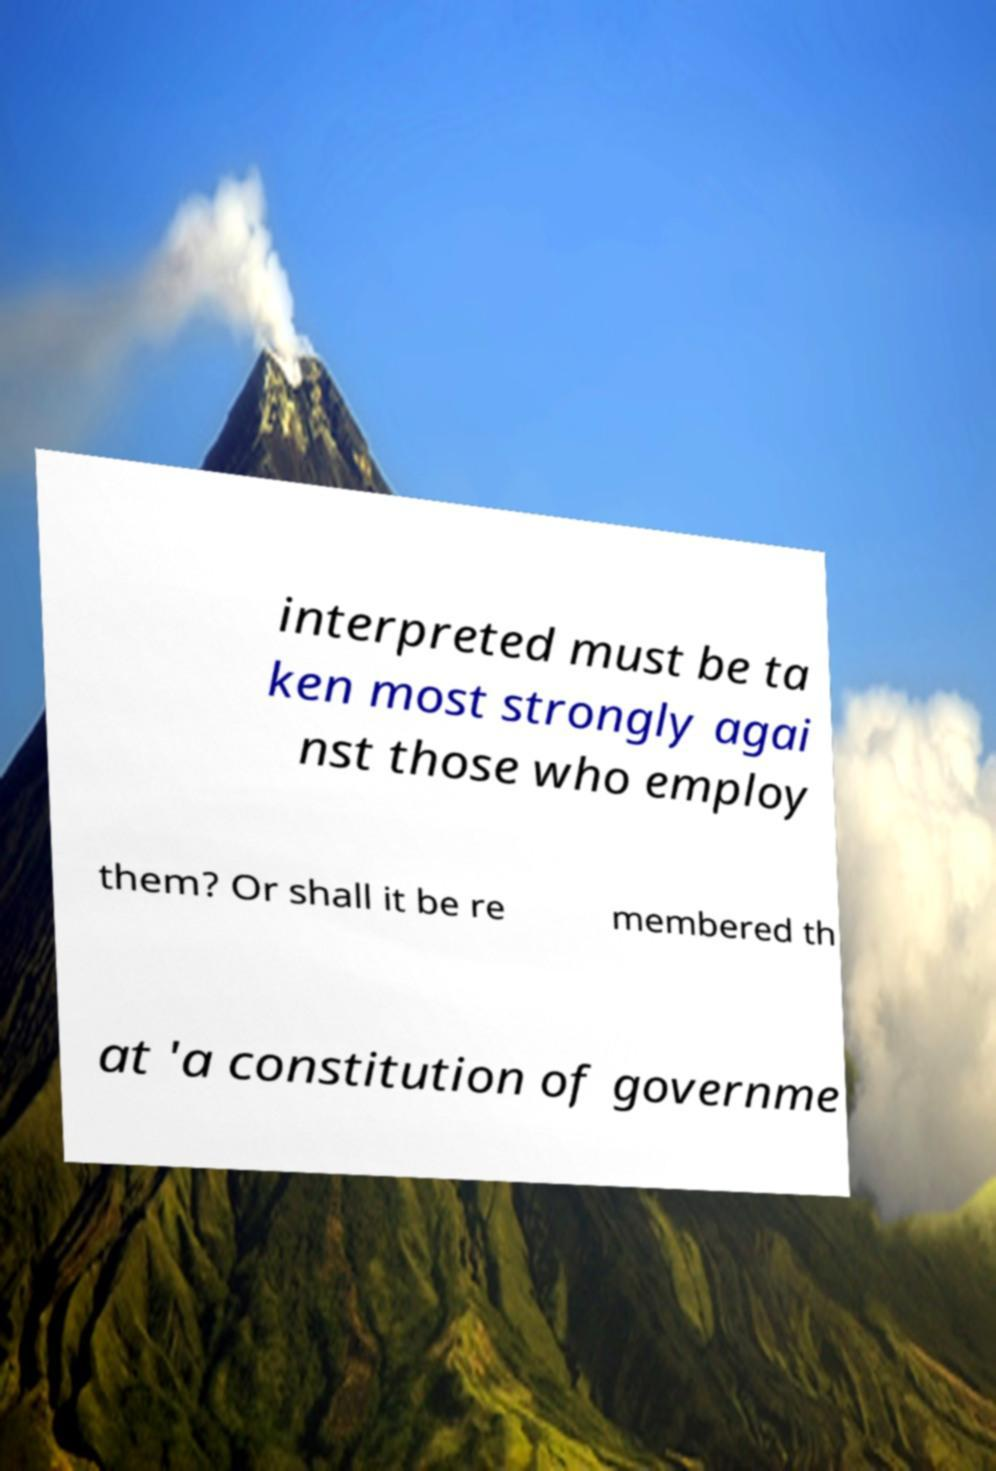Can you accurately transcribe the text from the provided image for me? interpreted must be ta ken most strongly agai nst those who employ them? Or shall it be re membered th at 'a constitution of governme 